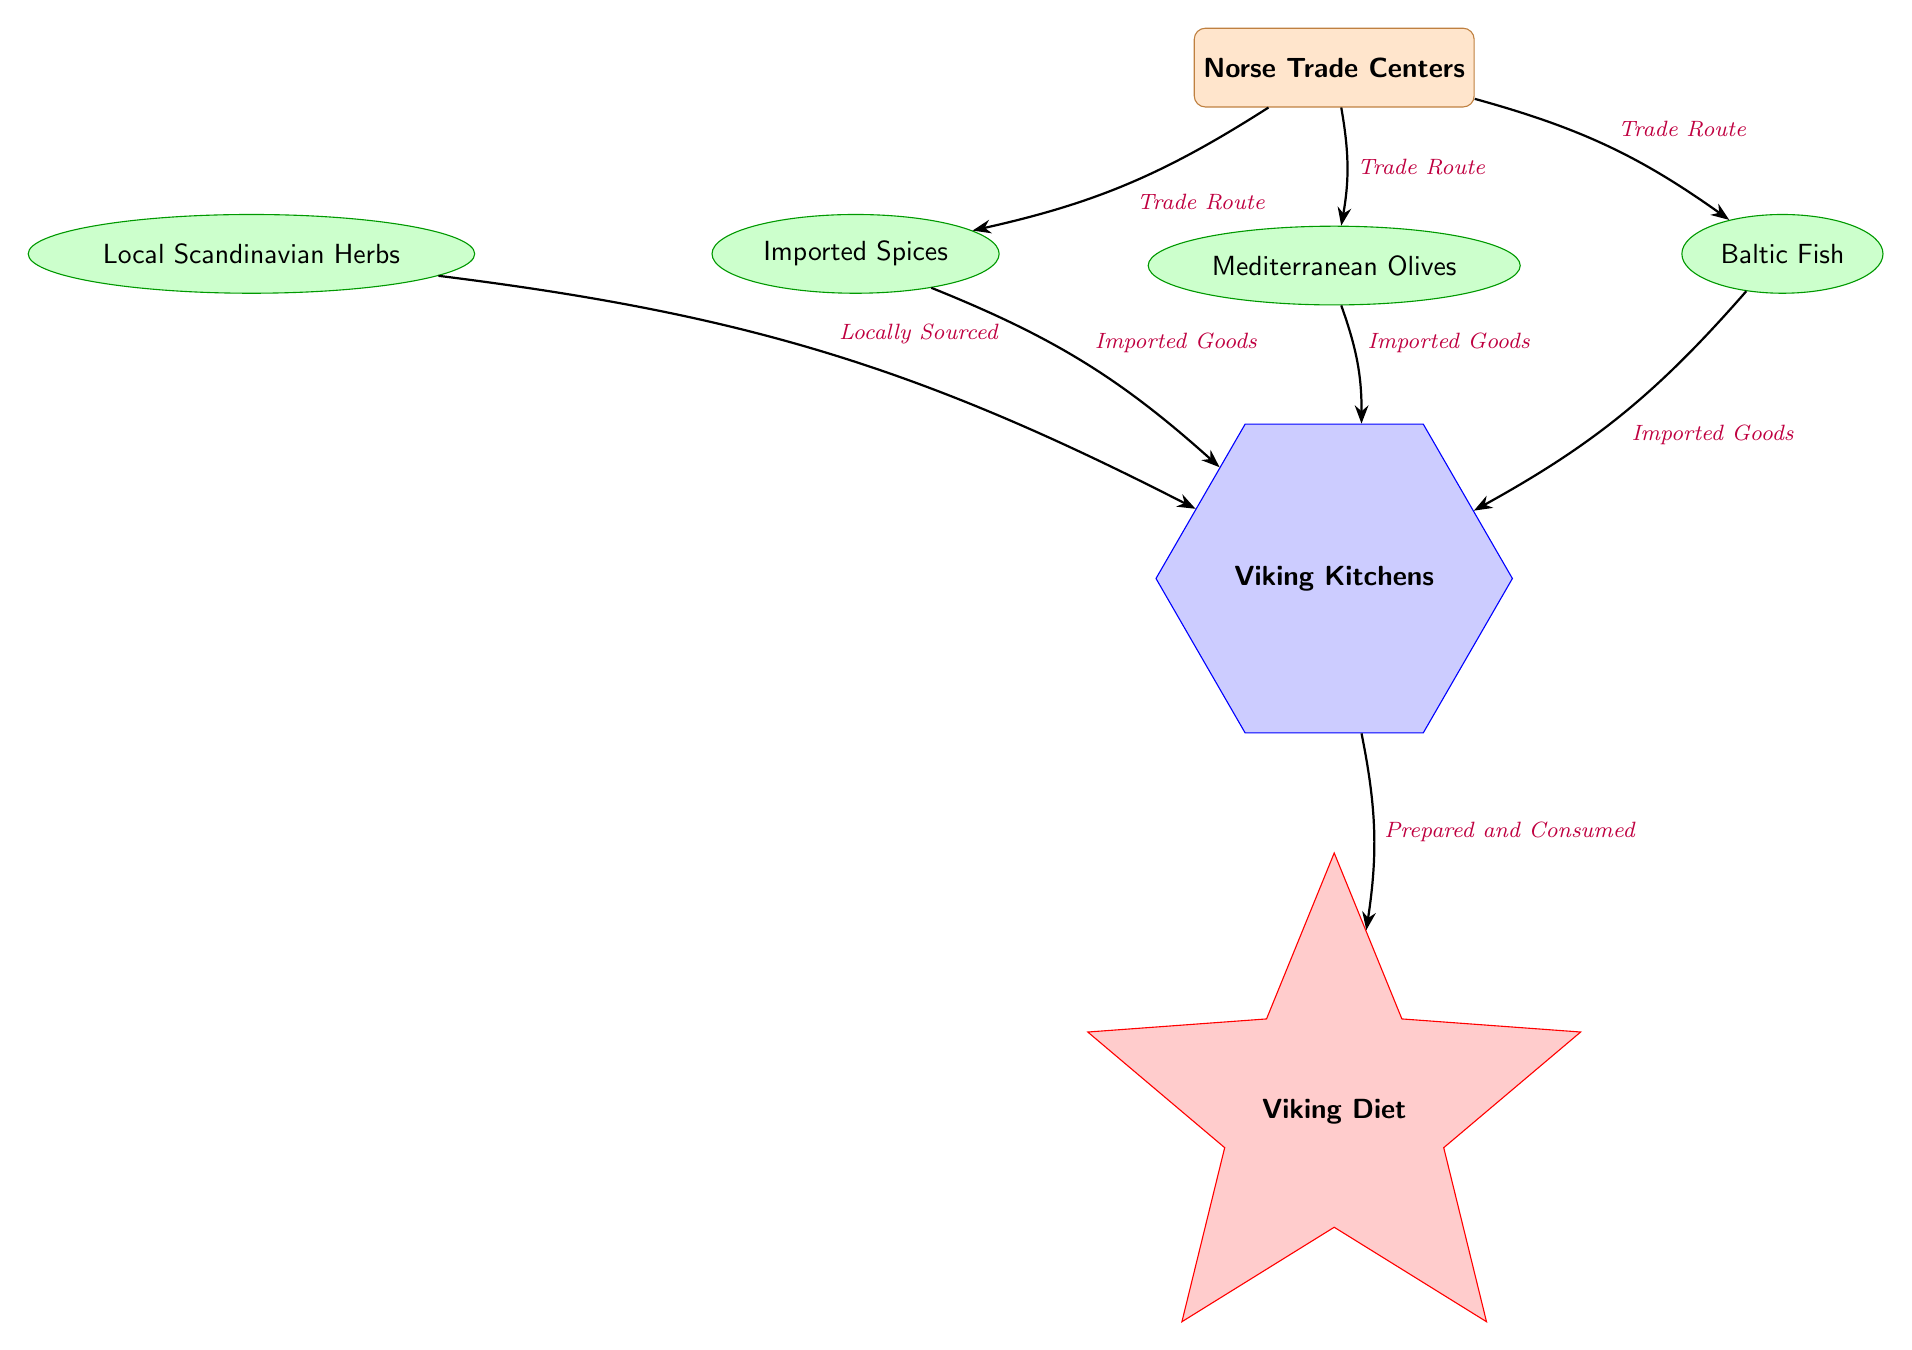What are the goods traded from Norse Trade Centers? The diagram shows three goods that are traded from Norse Trade Centers: Imported Spices, Mediterranean Olives, and Baltic Fish, which are directly connected to the Norse Trade Centers.
Answer: Imported Spices, Mediterranean Olives, Baltic Fish How many goods are sourced locally in Viking Kitchens? Observing the diagram, there is only one good sourced locally, which is Local Scandinavian Herbs, as it connects directly to Viking Kitchens with a "Locally Sourced" edge.
Answer: 1 What is the final result of the goods processed in Viking Kitchens? The diagram indicates that all goods prepared in Viking Kitchens lead to the final output labeled Viking Diet, which shows the outcome of the preparation process.
Answer: Viking Diet What type of relationship exists between Local Scandinavian Herbs and Viking Kitchens? The diagram illustrates that the relationship is characterized as "Locally Sourced," which indicates the nature of the connection from the Local Scandinavian Herbs to Viking Kitchens.
Answer: Locally Sourced How many trade routes connect Norse Trade Centers to other nodes? By examining the edges connected to the Norse Trade Centers, I see three distinct trade routes leading to Imported Spices, Mediterranean Olives, and Baltic Fish.
Answer: 3 Which goods are considered imported in the Viking Kitchens? The diagram depicts three specific goods that are regarded as "Imported Goods" when connected to Viking Kitchens: Imported Spices, Mediterranean Olives, and Baltic Fish, highlighting their source.
Answer: Imported Spices, Mediterranean Olives, Baltic Fish What does the edge from Viking Kitchens to Viking Diet signify? The edge signifies the "Prepared and Consumed" relationship, meaning that goods processed in Viking Kitchens are transformed into the Viking Diet as a final product or outcome.
Answer: Prepared and Consumed What connects Local Scandinavian Herbs directly to Viking Kitchens? The direct connection is established through the locally sourced relationship indicated by the edge labeled "Locally Sourced" that flows from Local Scandinavian Herbs to Viking Kitchens.
Answer: Locally Sourced Which goods are directly linked to the Norse Trade Centers? The diagram clearly shows that the Norse Trade Centers are directly linked to three goods: Imported Spices, Mediterranean Olives, and Baltic Fish, as represented by the edges.
Answer: Imported Spices, Mediterranean Olives, Baltic Fish 